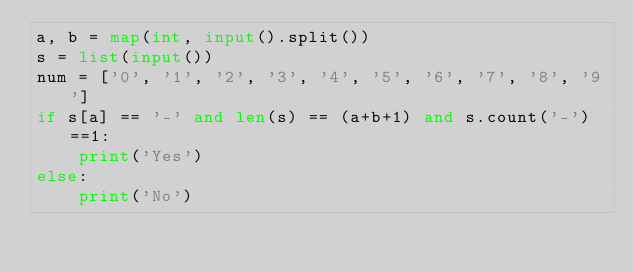Convert code to text. <code><loc_0><loc_0><loc_500><loc_500><_Python_>a, b = map(int, input().split())
s = list(input())
num = ['0', '1', '2', '3', '4', '5', '6', '7', '8', '9']
if s[a] == '-' and len(s) == (a+b+1) and s.count('-')==1:
    print('Yes')
else:
    print('No')</code> 